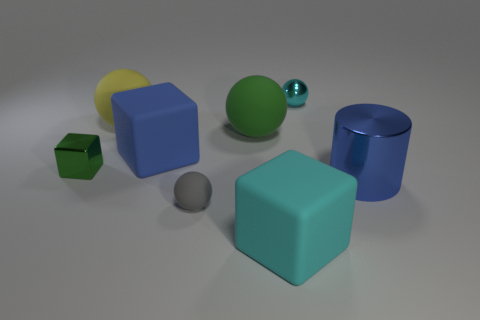There is a ball that is on the right side of the large matte object to the right of the green rubber thing behind the tiny green cube; what size is it?
Your response must be concise. Small. What number of other things are there of the same size as the metal cylinder?
Your answer should be compact. 4. How many cylinders are the same material as the large yellow thing?
Offer a very short reply. 0. What is the shape of the green object that is on the right side of the small green shiny thing?
Make the answer very short. Sphere. Is the material of the cylinder the same as the big ball left of the small gray rubber thing?
Your answer should be very brief. No. Are there any tiny metallic things?
Offer a terse response. Yes. Is there a metallic thing that is behind the tiny metallic thing to the left of the tiny metal object that is behind the large yellow ball?
Give a very brief answer. Yes. How many tiny things are either green metal objects or blue things?
Ensure brevity in your answer.  1. What color is the matte ball that is the same size as the cyan metallic sphere?
Offer a terse response. Gray. What number of metallic objects are on the left side of the large shiny cylinder?
Provide a succinct answer. 2. 